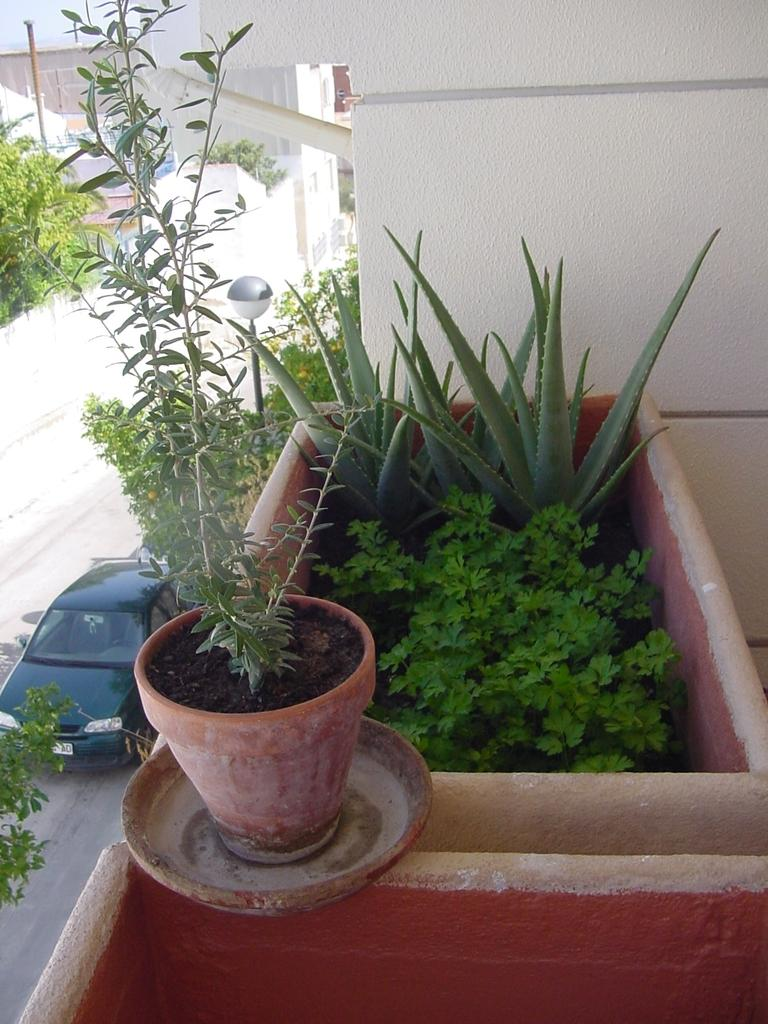What is located in the center of the image? There are flower pots in the center of the image. What can be seen in the background of the image? There is a wall in the background of the image. Where is the car positioned in the image? The car is on the left side of the image. What type of pathway is visible in the image? There is a road visible in the image. What type of bun is being used to coil the wire in the image? There is no bun or wire present in the image; it features flower pots, a wall, a car, and a road. Can you tell me who is having an argument in the image? There is no argument or people present in the image; it only shows flower pots, a wall, a car, and a road. 